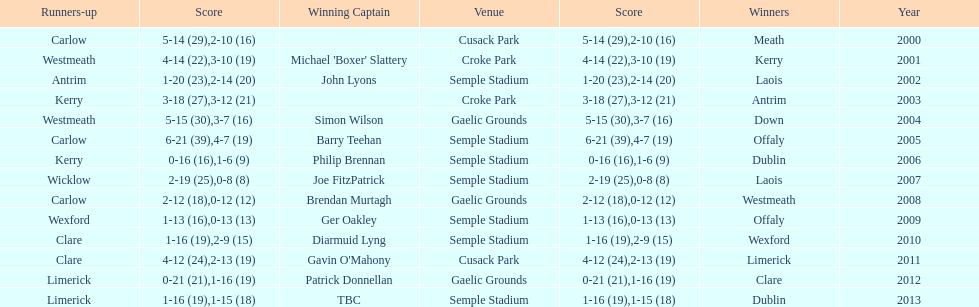How many times was carlow the runner-up? 3. 